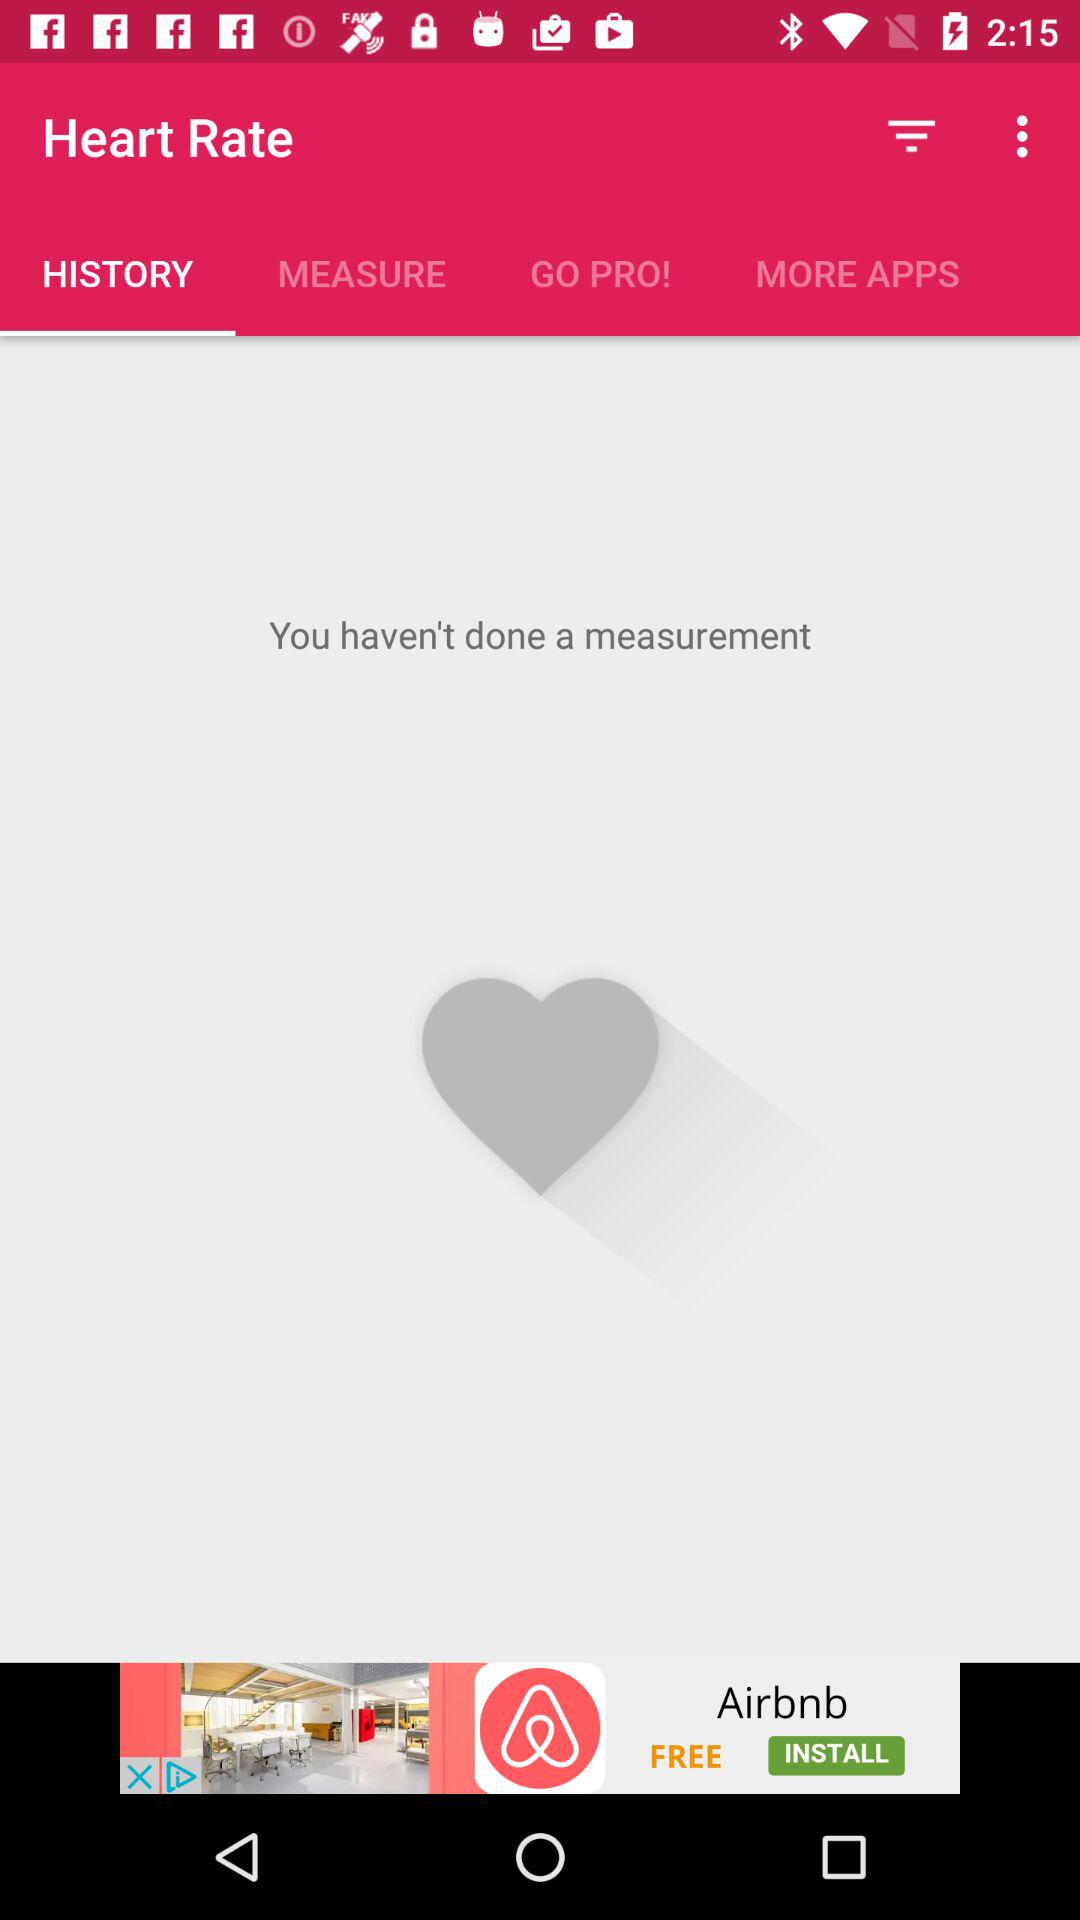What is the application name? The application name is Heart Rate. 